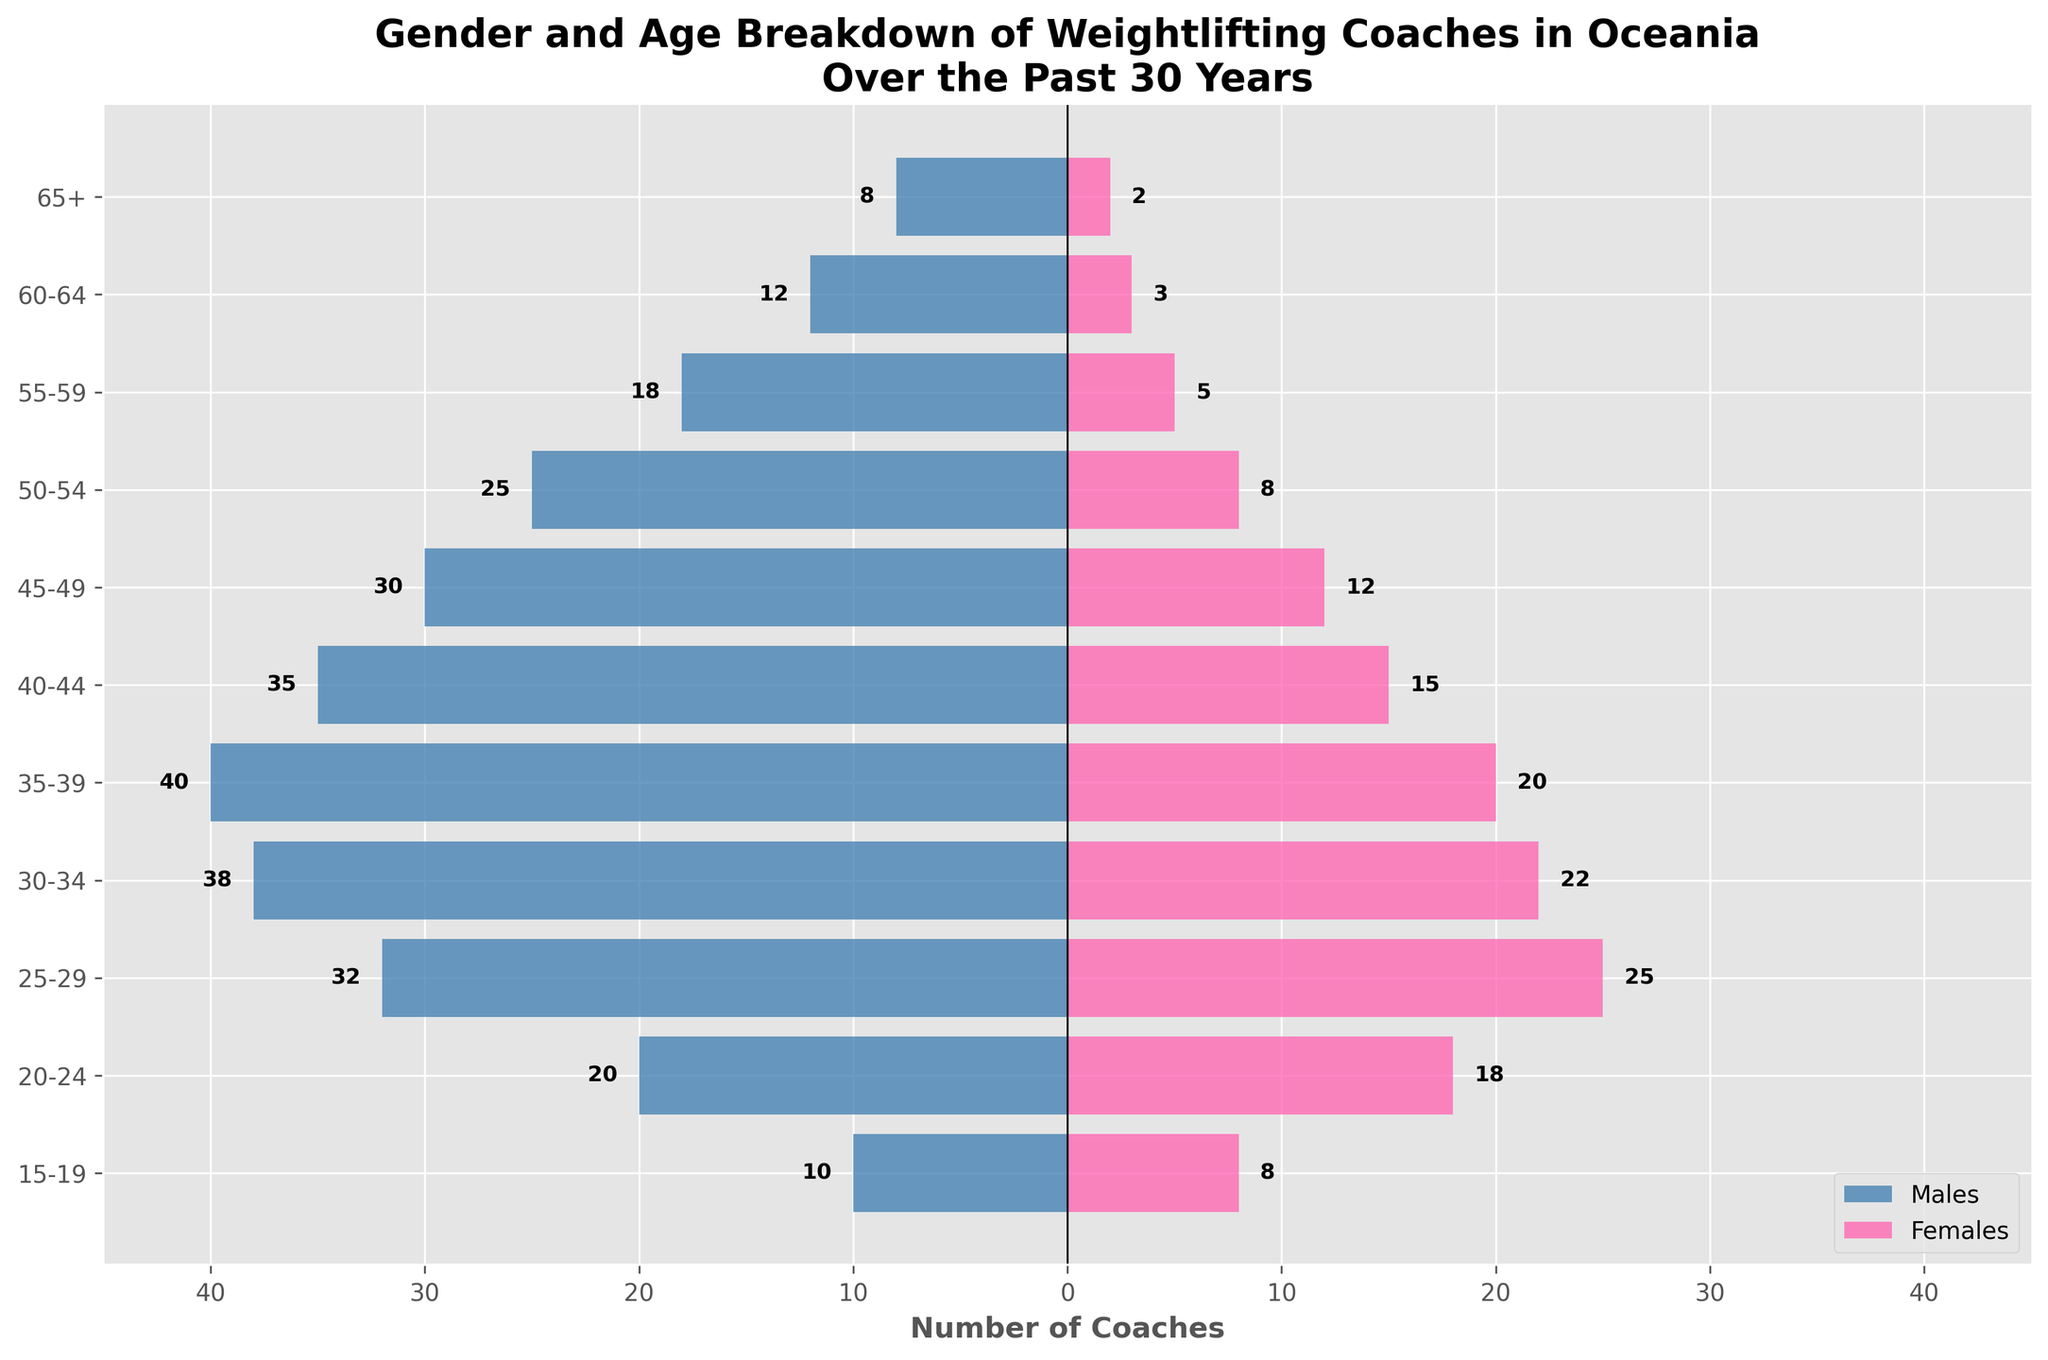what is the title of the figure? The title of a figure typically appears at the top. Inspecting the visual layout, the text at the top of the figure reads: "Gender and Age Breakdown of Weightlifting Coaches in Oceania Over the Past 30 Years".
Answer: Gender and Age Breakdown of Weightlifting Coaches in Oceania Over the Past 30 Years Which age group has the most female coaches? We need to look at the bars on the right side designated for females. The longest bar on the right corresponds to the 25-29 age group with 25 coaches.
Answer: 25-29 How many male coaches are there in the 50-54 age group? We need to find the bar on the left side (for males) associated with the 50-54 age group. The length of the bar shows the value of 25 coaches.
Answer: 25 What is the age group with the least total number of coaches? To determine this, add the male and female coaches for each age group and find the minimum total. Calculations:
15-19: 10 + 8 = 18,
20-24: 20 + 18 = 38,
25-29: 32 + 25 = 57,
30-34: 38 + 22 = 60,
35-39: 40 + 20 = 60,
40-44: 35 + 15 = 50,
45-49: 30 + 12 = 42,
50-54: 25 + 8 = 33,
55-59: 18 + 5 = 23,
60-64: 12 + 3 = 15,
65+: 8 + 2 = 10. 
The age group 65+ has the least total number of coaches with a sum of 10.
Answer: 65+ Which gender has more coaches in the 30-34 age group, and by how much? Look at the bars for the 30-34 age group for both males and females. Males: 38, Females: 22. The difference is 38 - 22 = 16, with males having more coaches.
Answer: Males, by 16 What is the total number of female coaches across all age groups? Sum all the values from the female column:
2 + 3 + 5 + 8 + 12 + 15 + 20 + 22 + 25 + 18 + 8 = 138.
Answer: 138 In which age groups are the number of male and female coaches equal? Compare the values for males and females in each age group. In all age groups, the numbers are different. Therefore, there is no age group where male and female coaches are equal.
Answer: None What percentage of the total number of coaches are in the 40-44 age group? First, find the total number of coaches: Males: (Quantity) 268, Females: 138, Total: 406. Age group 40-44: Males: 35, Females: 15, Total: 50. 
Percentage: \( (50/406) \times 100 \approx 12.32\% \).
Answer: Approximately 12.32% Which age group has more male coaches on average between 25-29 and 35-39? Calculate the average number of male coaches in each age group:
25-29: 32,
35-39: 40. Compare: 40 is greater than 32.
Answer: 35-39 How much has the number of female coaches in the age group 20-24 increased compared to the 15-19 age group? Compare the number of female coaches in the 20-24 age group with the 15-19 age group. 20-24: 18, 15-19: 8. Increase: 18 - 8 = 10.
Answer: Increased by 10 